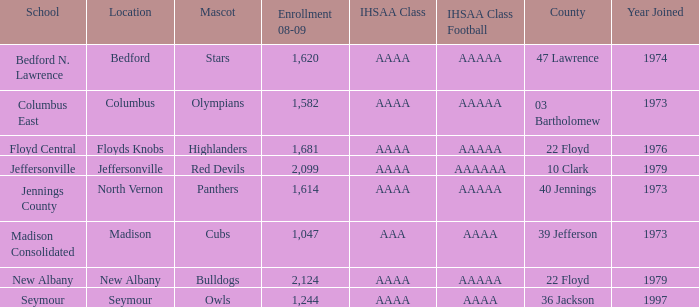What's the IHSAA Class Football if the panthers are the mascot? AAAAA. 